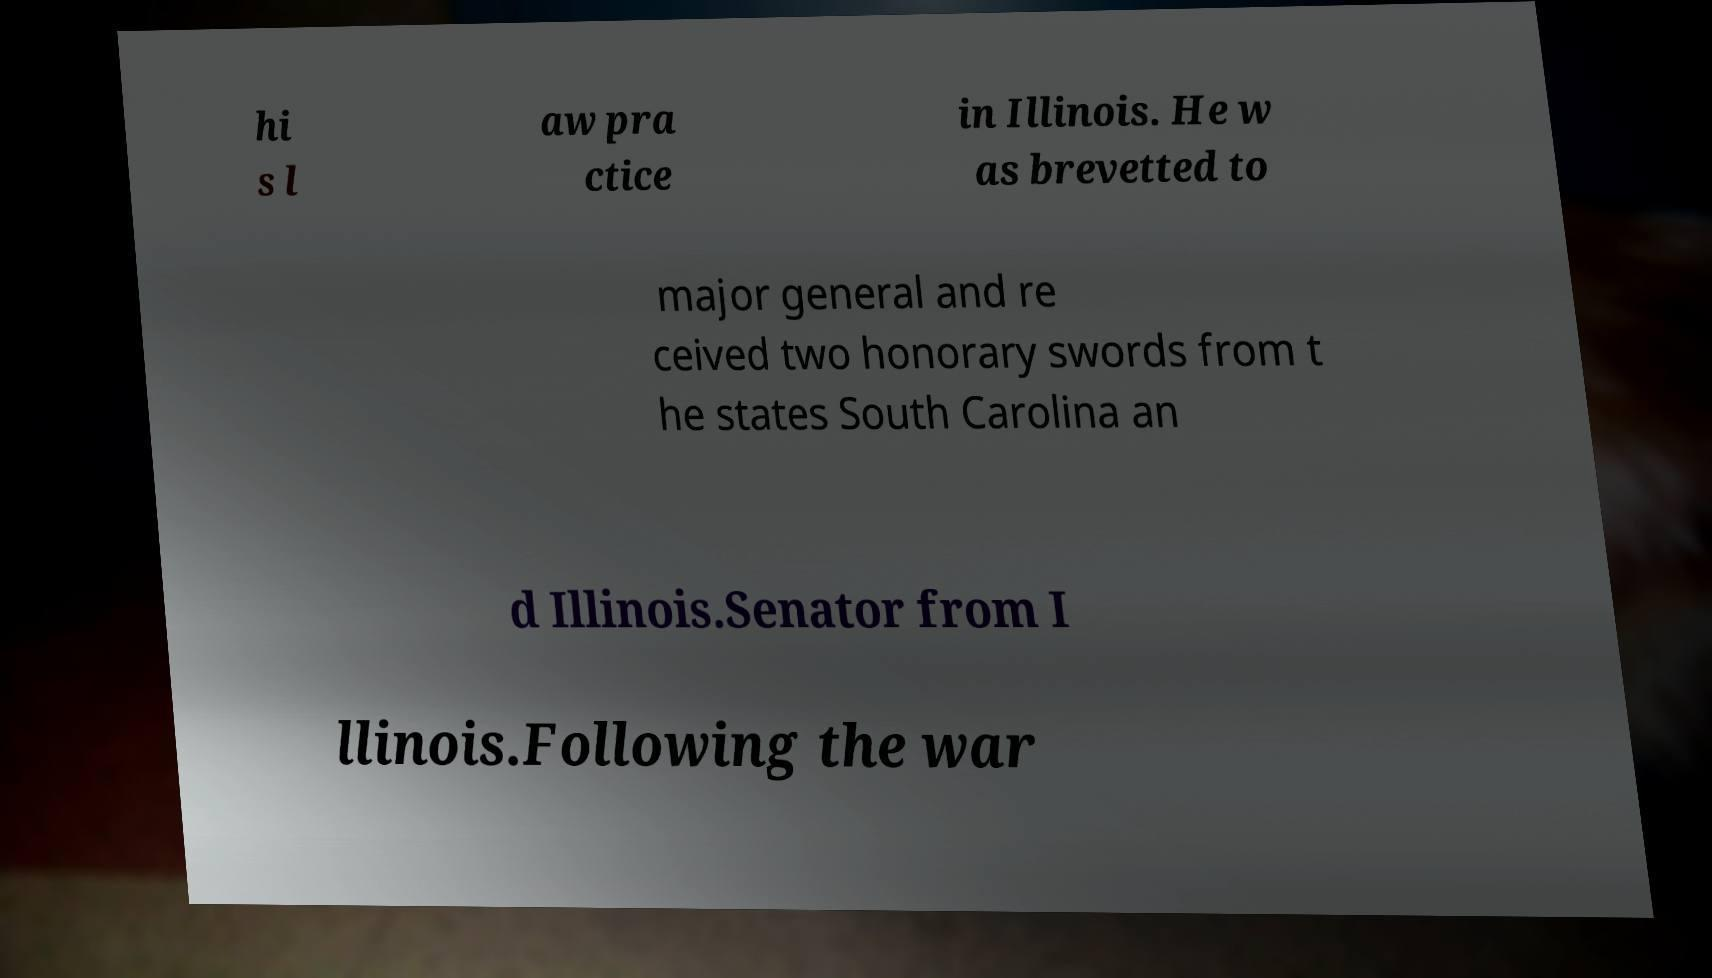For documentation purposes, I need the text within this image transcribed. Could you provide that? hi s l aw pra ctice in Illinois. He w as brevetted to major general and re ceived two honorary swords from t he states South Carolina an d Illinois.Senator from I llinois.Following the war 